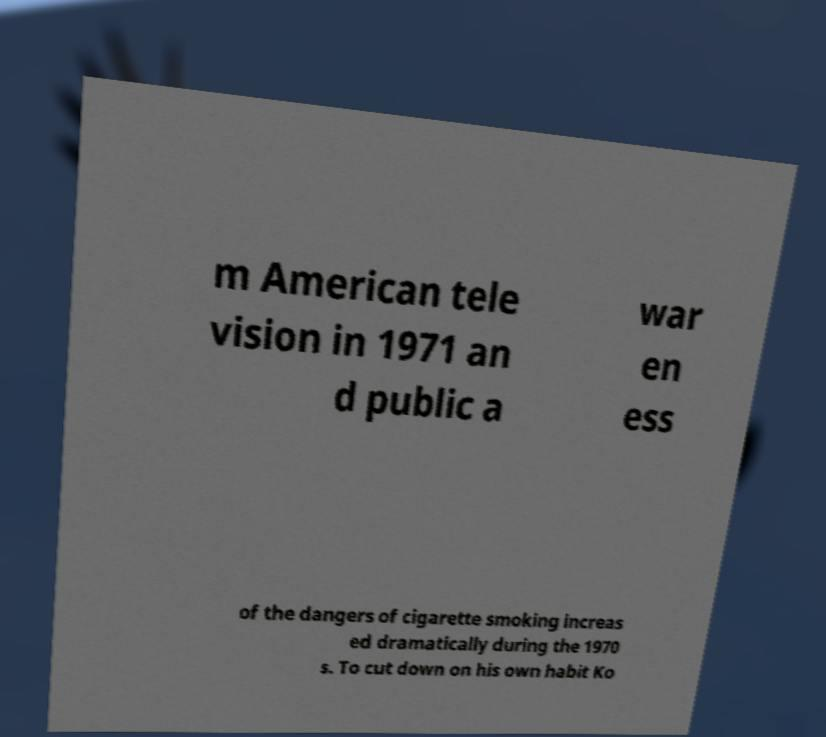Could you assist in decoding the text presented in this image and type it out clearly? m American tele vision in 1971 an d public a war en ess of the dangers of cigarette smoking increas ed dramatically during the 1970 s. To cut down on his own habit Ko 